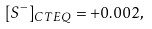<formula> <loc_0><loc_0><loc_500><loc_500>[ S ^ { - } ] _ { C T E Q } = + 0 . 0 0 2 ,</formula> 